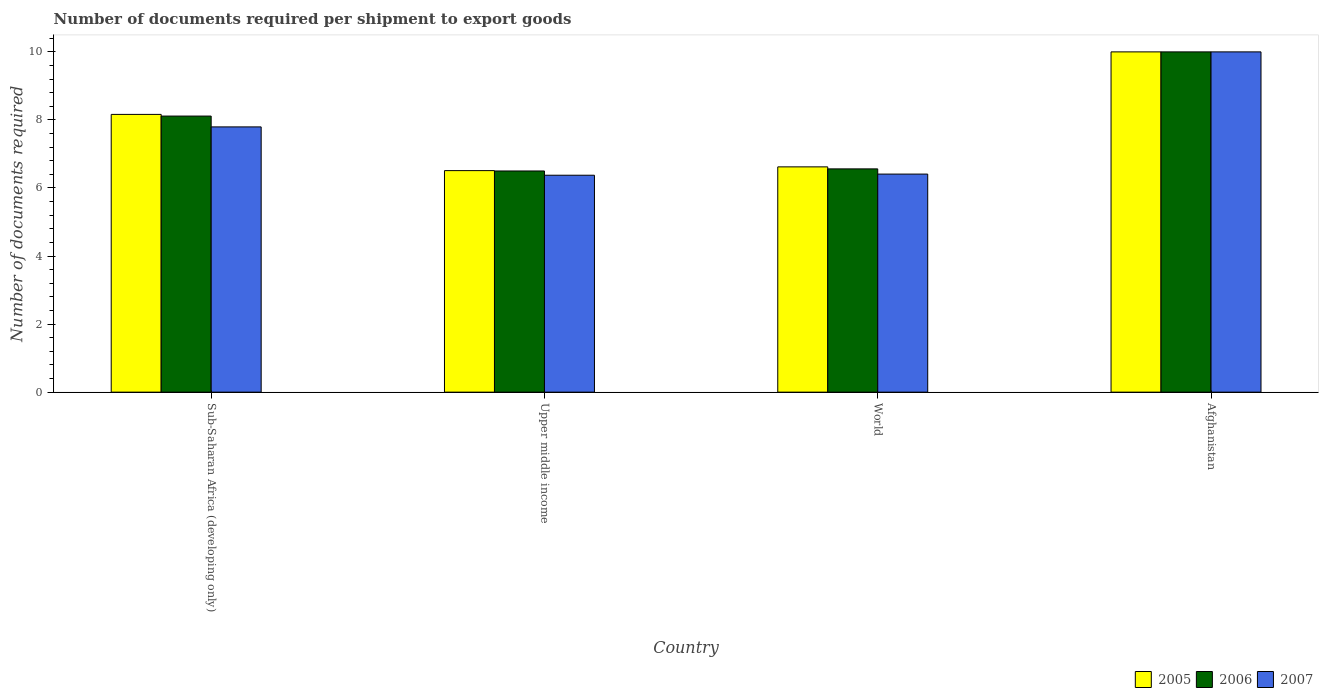How many different coloured bars are there?
Provide a short and direct response. 3. How many groups of bars are there?
Ensure brevity in your answer.  4. Are the number of bars per tick equal to the number of legend labels?
Offer a very short reply. Yes. Are the number of bars on each tick of the X-axis equal?
Provide a short and direct response. Yes. How many bars are there on the 2nd tick from the right?
Your answer should be compact. 3. What is the label of the 2nd group of bars from the left?
Make the answer very short. Upper middle income. What is the number of documents required per shipment to export goods in 2005 in World?
Make the answer very short. 6.62. Across all countries, what is the maximum number of documents required per shipment to export goods in 2007?
Your answer should be compact. 10. In which country was the number of documents required per shipment to export goods in 2005 maximum?
Your answer should be compact. Afghanistan. In which country was the number of documents required per shipment to export goods in 2007 minimum?
Provide a succinct answer. Upper middle income. What is the total number of documents required per shipment to export goods in 2007 in the graph?
Your answer should be compact. 30.58. What is the difference between the number of documents required per shipment to export goods in 2006 in Upper middle income and that in World?
Your answer should be very brief. -0.06. What is the difference between the number of documents required per shipment to export goods in 2005 in World and the number of documents required per shipment to export goods in 2006 in Upper middle income?
Keep it short and to the point. 0.12. What is the average number of documents required per shipment to export goods in 2007 per country?
Your answer should be compact. 7.64. What is the difference between the number of documents required per shipment to export goods of/in 2005 and number of documents required per shipment to export goods of/in 2006 in Upper middle income?
Offer a terse response. 0.01. What is the ratio of the number of documents required per shipment to export goods in 2005 in Sub-Saharan Africa (developing only) to that in World?
Offer a terse response. 1.23. Is the difference between the number of documents required per shipment to export goods in 2005 in Afghanistan and Sub-Saharan Africa (developing only) greater than the difference between the number of documents required per shipment to export goods in 2006 in Afghanistan and Sub-Saharan Africa (developing only)?
Your answer should be compact. No. What is the difference between the highest and the second highest number of documents required per shipment to export goods in 2005?
Offer a terse response. -1.84. What is the difference between the highest and the lowest number of documents required per shipment to export goods in 2006?
Your answer should be very brief. 3.5. In how many countries, is the number of documents required per shipment to export goods in 2006 greater than the average number of documents required per shipment to export goods in 2006 taken over all countries?
Offer a terse response. 2. Is the sum of the number of documents required per shipment to export goods in 2006 in Upper middle income and World greater than the maximum number of documents required per shipment to export goods in 2005 across all countries?
Offer a very short reply. Yes. What does the 3rd bar from the right in Upper middle income represents?
Keep it short and to the point. 2005. How are the legend labels stacked?
Your response must be concise. Horizontal. What is the title of the graph?
Your answer should be very brief. Number of documents required per shipment to export goods. Does "2001" appear as one of the legend labels in the graph?
Make the answer very short. No. What is the label or title of the X-axis?
Your answer should be very brief. Country. What is the label or title of the Y-axis?
Your answer should be compact. Number of documents required. What is the Number of documents required in 2005 in Sub-Saharan Africa (developing only)?
Give a very brief answer. 8.16. What is the Number of documents required in 2006 in Sub-Saharan Africa (developing only)?
Provide a succinct answer. 8.11. What is the Number of documents required of 2007 in Sub-Saharan Africa (developing only)?
Ensure brevity in your answer.  7.8. What is the Number of documents required of 2005 in Upper middle income?
Ensure brevity in your answer.  6.51. What is the Number of documents required of 2007 in Upper middle income?
Your answer should be very brief. 6.38. What is the Number of documents required of 2005 in World?
Offer a very short reply. 6.62. What is the Number of documents required of 2006 in World?
Make the answer very short. 6.56. What is the Number of documents required of 2007 in World?
Give a very brief answer. 6.41. What is the Number of documents required of 2005 in Afghanistan?
Provide a succinct answer. 10. Across all countries, what is the maximum Number of documents required of 2005?
Offer a terse response. 10. Across all countries, what is the maximum Number of documents required of 2007?
Ensure brevity in your answer.  10. Across all countries, what is the minimum Number of documents required of 2005?
Offer a terse response. 6.51. Across all countries, what is the minimum Number of documents required of 2007?
Your answer should be compact. 6.38. What is the total Number of documents required of 2005 in the graph?
Keep it short and to the point. 31.29. What is the total Number of documents required in 2006 in the graph?
Keep it short and to the point. 31.18. What is the total Number of documents required in 2007 in the graph?
Make the answer very short. 30.58. What is the difference between the Number of documents required in 2005 in Sub-Saharan Africa (developing only) and that in Upper middle income?
Offer a very short reply. 1.65. What is the difference between the Number of documents required in 2006 in Sub-Saharan Africa (developing only) and that in Upper middle income?
Give a very brief answer. 1.61. What is the difference between the Number of documents required of 2007 in Sub-Saharan Africa (developing only) and that in Upper middle income?
Ensure brevity in your answer.  1.42. What is the difference between the Number of documents required of 2005 in Sub-Saharan Africa (developing only) and that in World?
Provide a short and direct response. 1.54. What is the difference between the Number of documents required in 2006 in Sub-Saharan Africa (developing only) and that in World?
Offer a terse response. 1.55. What is the difference between the Number of documents required in 2007 in Sub-Saharan Africa (developing only) and that in World?
Offer a terse response. 1.39. What is the difference between the Number of documents required in 2005 in Sub-Saharan Africa (developing only) and that in Afghanistan?
Ensure brevity in your answer.  -1.84. What is the difference between the Number of documents required of 2006 in Sub-Saharan Africa (developing only) and that in Afghanistan?
Offer a very short reply. -1.89. What is the difference between the Number of documents required of 2007 in Sub-Saharan Africa (developing only) and that in Afghanistan?
Your response must be concise. -2.2. What is the difference between the Number of documents required in 2005 in Upper middle income and that in World?
Provide a short and direct response. -0.11. What is the difference between the Number of documents required in 2006 in Upper middle income and that in World?
Your answer should be compact. -0.06. What is the difference between the Number of documents required in 2007 in Upper middle income and that in World?
Your answer should be very brief. -0.03. What is the difference between the Number of documents required in 2005 in Upper middle income and that in Afghanistan?
Keep it short and to the point. -3.49. What is the difference between the Number of documents required in 2007 in Upper middle income and that in Afghanistan?
Make the answer very short. -3.62. What is the difference between the Number of documents required of 2005 in World and that in Afghanistan?
Provide a succinct answer. -3.38. What is the difference between the Number of documents required in 2006 in World and that in Afghanistan?
Give a very brief answer. -3.44. What is the difference between the Number of documents required in 2007 in World and that in Afghanistan?
Your answer should be very brief. -3.59. What is the difference between the Number of documents required in 2005 in Sub-Saharan Africa (developing only) and the Number of documents required in 2006 in Upper middle income?
Your response must be concise. 1.66. What is the difference between the Number of documents required in 2005 in Sub-Saharan Africa (developing only) and the Number of documents required in 2007 in Upper middle income?
Provide a succinct answer. 1.79. What is the difference between the Number of documents required in 2006 in Sub-Saharan Africa (developing only) and the Number of documents required in 2007 in Upper middle income?
Offer a terse response. 1.74. What is the difference between the Number of documents required of 2005 in Sub-Saharan Africa (developing only) and the Number of documents required of 2006 in World?
Provide a succinct answer. 1.6. What is the difference between the Number of documents required in 2005 in Sub-Saharan Africa (developing only) and the Number of documents required in 2007 in World?
Give a very brief answer. 1.75. What is the difference between the Number of documents required of 2006 in Sub-Saharan Africa (developing only) and the Number of documents required of 2007 in World?
Give a very brief answer. 1.7. What is the difference between the Number of documents required of 2005 in Sub-Saharan Africa (developing only) and the Number of documents required of 2006 in Afghanistan?
Offer a terse response. -1.84. What is the difference between the Number of documents required of 2005 in Sub-Saharan Africa (developing only) and the Number of documents required of 2007 in Afghanistan?
Keep it short and to the point. -1.84. What is the difference between the Number of documents required of 2006 in Sub-Saharan Africa (developing only) and the Number of documents required of 2007 in Afghanistan?
Offer a very short reply. -1.89. What is the difference between the Number of documents required in 2005 in Upper middle income and the Number of documents required in 2006 in World?
Ensure brevity in your answer.  -0.05. What is the difference between the Number of documents required of 2005 in Upper middle income and the Number of documents required of 2007 in World?
Your answer should be very brief. 0.1. What is the difference between the Number of documents required of 2006 in Upper middle income and the Number of documents required of 2007 in World?
Provide a short and direct response. 0.09. What is the difference between the Number of documents required in 2005 in Upper middle income and the Number of documents required in 2006 in Afghanistan?
Your answer should be compact. -3.49. What is the difference between the Number of documents required in 2005 in Upper middle income and the Number of documents required in 2007 in Afghanistan?
Your answer should be compact. -3.49. What is the difference between the Number of documents required in 2006 in Upper middle income and the Number of documents required in 2007 in Afghanistan?
Make the answer very short. -3.5. What is the difference between the Number of documents required in 2005 in World and the Number of documents required in 2006 in Afghanistan?
Offer a terse response. -3.38. What is the difference between the Number of documents required in 2005 in World and the Number of documents required in 2007 in Afghanistan?
Offer a very short reply. -3.38. What is the difference between the Number of documents required in 2006 in World and the Number of documents required in 2007 in Afghanistan?
Offer a terse response. -3.44. What is the average Number of documents required of 2005 per country?
Provide a succinct answer. 7.82. What is the average Number of documents required of 2006 per country?
Your answer should be very brief. 7.79. What is the average Number of documents required in 2007 per country?
Ensure brevity in your answer.  7.64. What is the difference between the Number of documents required of 2005 and Number of documents required of 2006 in Sub-Saharan Africa (developing only)?
Ensure brevity in your answer.  0.05. What is the difference between the Number of documents required of 2005 and Number of documents required of 2007 in Sub-Saharan Africa (developing only)?
Keep it short and to the point. 0.37. What is the difference between the Number of documents required of 2006 and Number of documents required of 2007 in Sub-Saharan Africa (developing only)?
Provide a short and direct response. 0.32. What is the difference between the Number of documents required of 2005 and Number of documents required of 2006 in Upper middle income?
Offer a very short reply. 0.01. What is the difference between the Number of documents required of 2005 and Number of documents required of 2007 in Upper middle income?
Your answer should be compact. 0.14. What is the difference between the Number of documents required in 2006 and Number of documents required in 2007 in Upper middle income?
Keep it short and to the point. 0.12. What is the difference between the Number of documents required of 2005 and Number of documents required of 2006 in World?
Provide a short and direct response. 0.06. What is the difference between the Number of documents required in 2005 and Number of documents required in 2007 in World?
Your response must be concise. 0.21. What is the difference between the Number of documents required of 2006 and Number of documents required of 2007 in World?
Offer a very short reply. 0.15. What is the difference between the Number of documents required of 2005 and Number of documents required of 2006 in Afghanistan?
Your answer should be compact. 0. What is the difference between the Number of documents required of 2006 and Number of documents required of 2007 in Afghanistan?
Offer a very short reply. 0. What is the ratio of the Number of documents required in 2005 in Sub-Saharan Africa (developing only) to that in Upper middle income?
Your response must be concise. 1.25. What is the ratio of the Number of documents required of 2006 in Sub-Saharan Africa (developing only) to that in Upper middle income?
Give a very brief answer. 1.25. What is the ratio of the Number of documents required of 2007 in Sub-Saharan Africa (developing only) to that in Upper middle income?
Provide a succinct answer. 1.22. What is the ratio of the Number of documents required of 2005 in Sub-Saharan Africa (developing only) to that in World?
Make the answer very short. 1.23. What is the ratio of the Number of documents required in 2006 in Sub-Saharan Africa (developing only) to that in World?
Keep it short and to the point. 1.24. What is the ratio of the Number of documents required in 2007 in Sub-Saharan Africa (developing only) to that in World?
Give a very brief answer. 1.22. What is the ratio of the Number of documents required in 2005 in Sub-Saharan Africa (developing only) to that in Afghanistan?
Offer a very short reply. 0.82. What is the ratio of the Number of documents required of 2006 in Sub-Saharan Africa (developing only) to that in Afghanistan?
Give a very brief answer. 0.81. What is the ratio of the Number of documents required of 2007 in Sub-Saharan Africa (developing only) to that in Afghanistan?
Your answer should be compact. 0.78. What is the ratio of the Number of documents required of 2005 in Upper middle income to that in World?
Keep it short and to the point. 0.98. What is the ratio of the Number of documents required of 2006 in Upper middle income to that in World?
Provide a succinct answer. 0.99. What is the ratio of the Number of documents required of 2005 in Upper middle income to that in Afghanistan?
Offer a terse response. 0.65. What is the ratio of the Number of documents required of 2006 in Upper middle income to that in Afghanistan?
Your response must be concise. 0.65. What is the ratio of the Number of documents required of 2007 in Upper middle income to that in Afghanistan?
Give a very brief answer. 0.64. What is the ratio of the Number of documents required of 2005 in World to that in Afghanistan?
Your response must be concise. 0.66. What is the ratio of the Number of documents required of 2006 in World to that in Afghanistan?
Provide a succinct answer. 0.66. What is the ratio of the Number of documents required in 2007 in World to that in Afghanistan?
Make the answer very short. 0.64. What is the difference between the highest and the second highest Number of documents required in 2005?
Your answer should be compact. 1.84. What is the difference between the highest and the second highest Number of documents required in 2006?
Ensure brevity in your answer.  1.89. What is the difference between the highest and the second highest Number of documents required in 2007?
Provide a succinct answer. 2.2. What is the difference between the highest and the lowest Number of documents required of 2005?
Offer a terse response. 3.49. What is the difference between the highest and the lowest Number of documents required of 2007?
Provide a short and direct response. 3.62. 